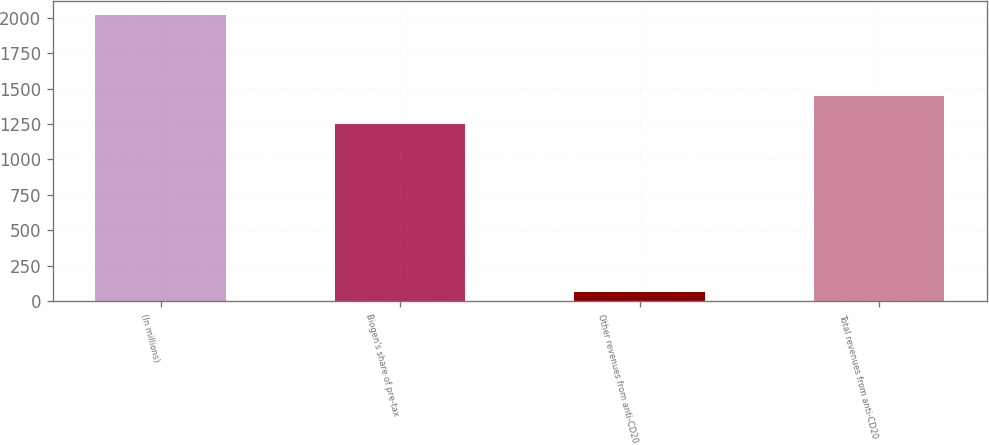<chart> <loc_0><loc_0><loc_500><loc_500><bar_chart><fcel>(In millions)<fcel>Biogen's share of pre-tax<fcel>Other revenues from anti-CD20<fcel>Total revenues from anti-CD20<nl><fcel>2016<fcel>1249.5<fcel>65<fcel>1444.6<nl></chart> 